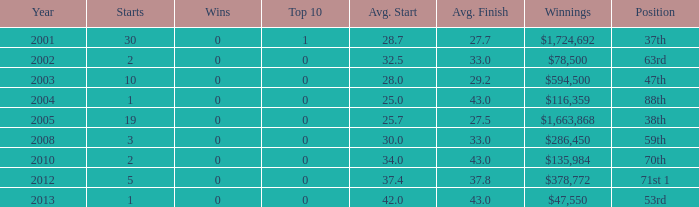How many triumphs for mean start under 25? 0.0. Can you parse all the data within this table? {'header': ['Year', 'Starts', 'Wins', 'Top 10', 'Avg. Start', 'Avg. Finish', 'Winnings', 'Position'], 'rows': [['2001', '30', '0', '1', '28.7', '27.7', '$1,724,692', '37th'], ['2002', '2', '0', '0', '32.5', '33.0', '$78,500', '63rd'], ['2003', '10', '0', '0', '28.0', '29.2', '$594,500', '47th'], ['2004', '1', '0', '0', '25.0', '43.0', '$116,359', '88th'], ['2005', '19', '0', '0', '25.7', '27.5', '$1,663,868', '38th'], ['2008', '3', '0', '0', '30.0', '33.0', '$286,450', '59th'], ['2010', '2', '0', '0', '34.0', '43.0', '$135,984', '70th'], ['2012', '5', '0', '0', '37.4', '37.8', '$378,772', '71st 1'], ['2013', '1', '0', '0', '42.0', '43.0', '$47,550', '53rd']]} 